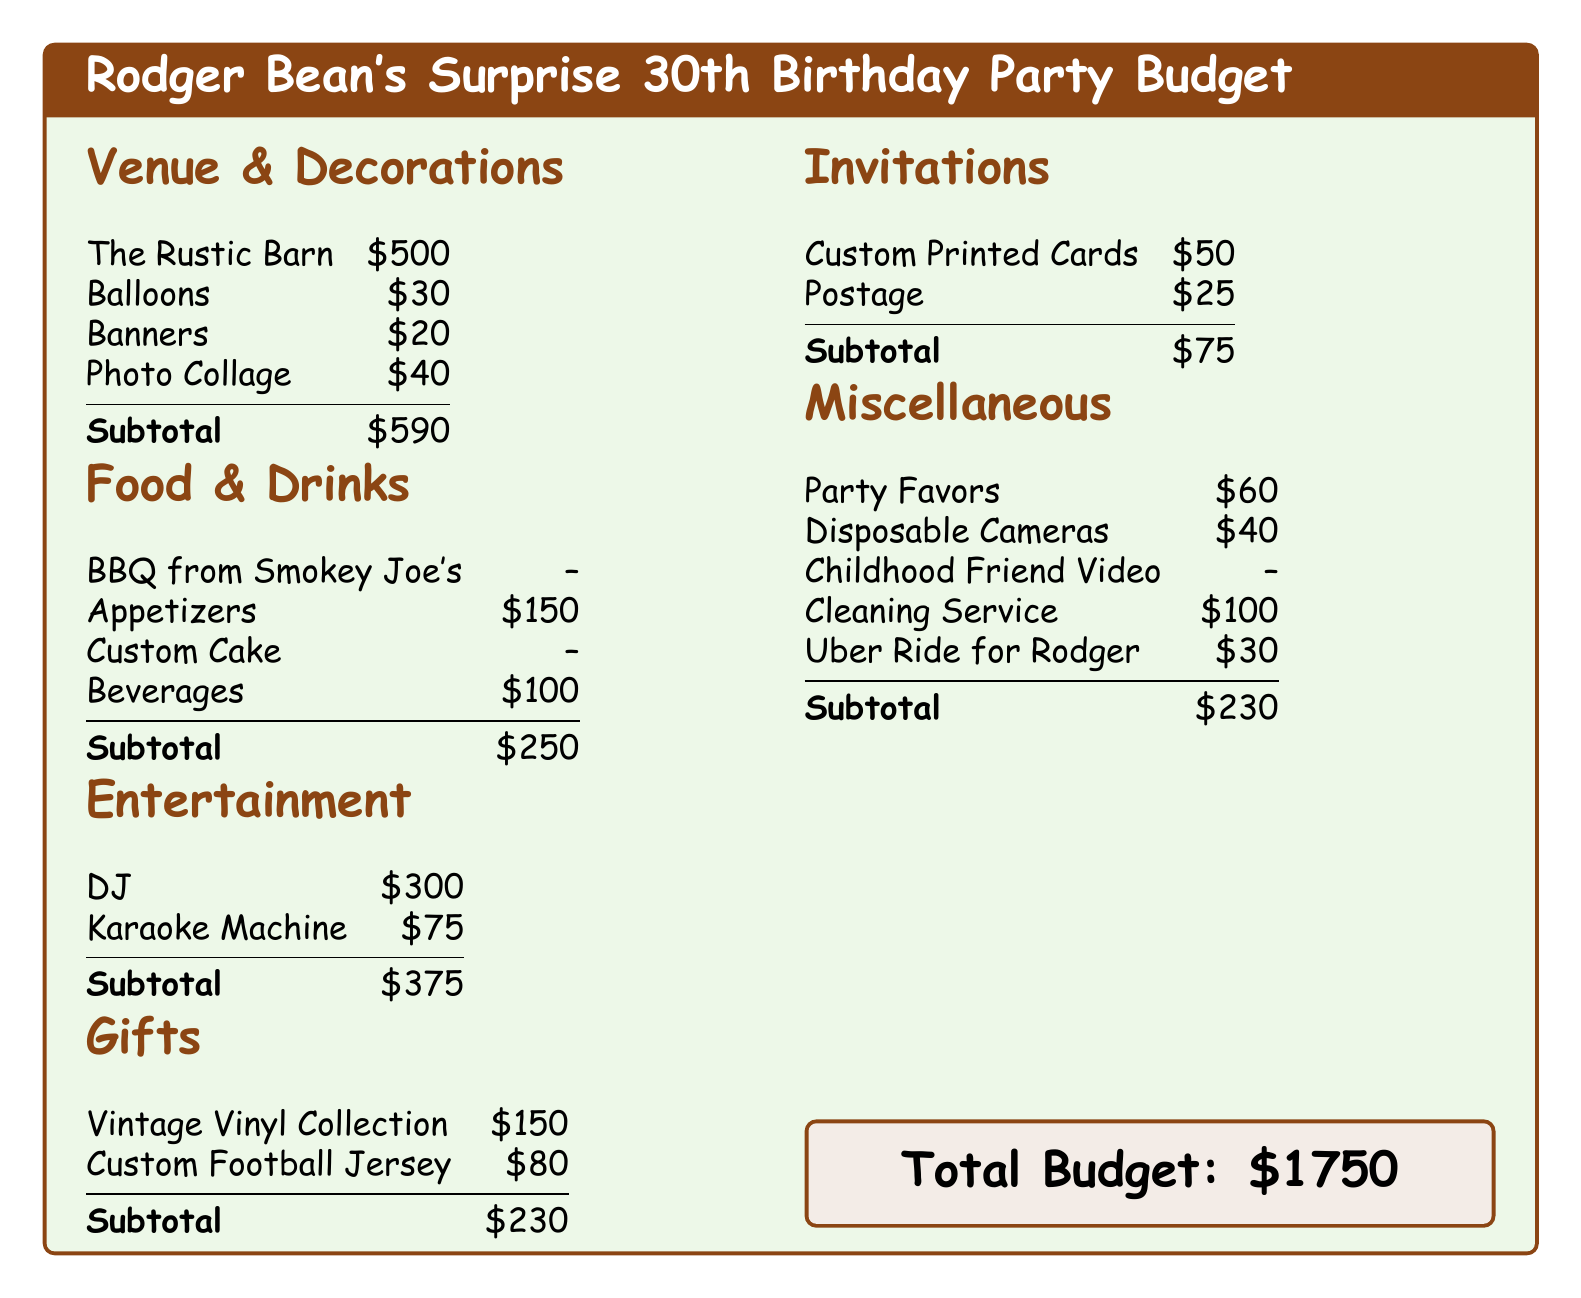What is the total budget for the party? The total budget is listed at the end of the document after all expense categories are summed.
Answer: $1750 How much is allocated for the DJ? The DJ's cost is specifically mentioned in the entertainment section of the budget.
Answer: $300 What is the cost of the Rustic Barn venue? The cost for the venue is found in the venue and decorations section of the budget list.
Answer: $500 What is the subtotal for food and drinks? The subtotal for food and drinks is provided after listing all related expenses in that section.
Answer: $250 How much is spent on the vintage vinyl collection? The amount for the vintage vinyl collection can be found in the gifts section of the document.
Answer: $150 What are the total costs for miscellaneous expenses? The miscellaneous expenses are summarized in their own section, with a total at the end.
Answer: $230 How much is allocated for the invitations? The value for invitations is detailed in its respective section of the budget.
Answer: $75 Which item has no cost listed in the budget? The document specifies certain items with no cost, requiring a look through the various sections.
Answer: Custom Cake How much is budgeted for party favors? The budget for party favors can be found under miscellaneous expenses.
Answer: $60 